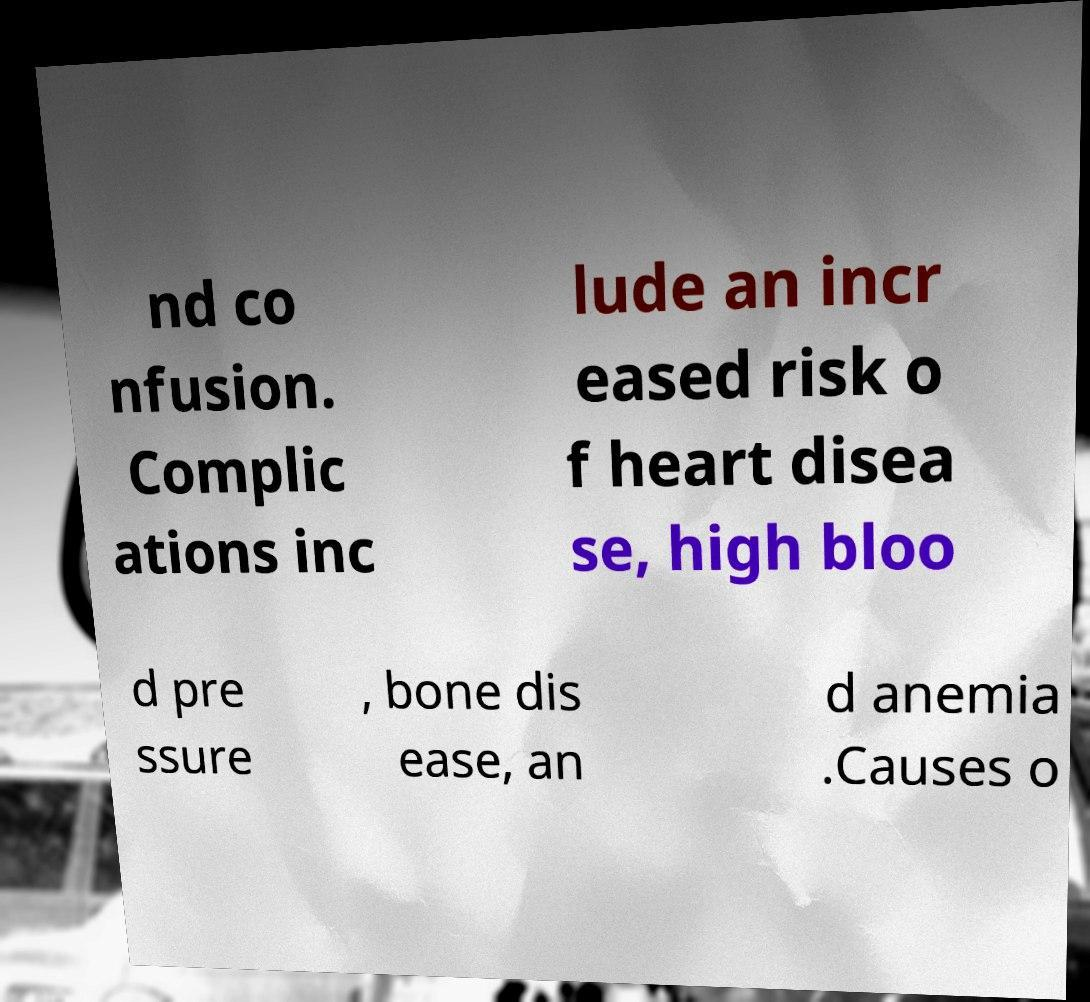Please identify and transcribe the text found in this image. nd co nfusion. Complic ations inc lude an incr eased risk o f heart disea se, high bloo d pre ssure , bone dis ease, an d anemia .Causes o 